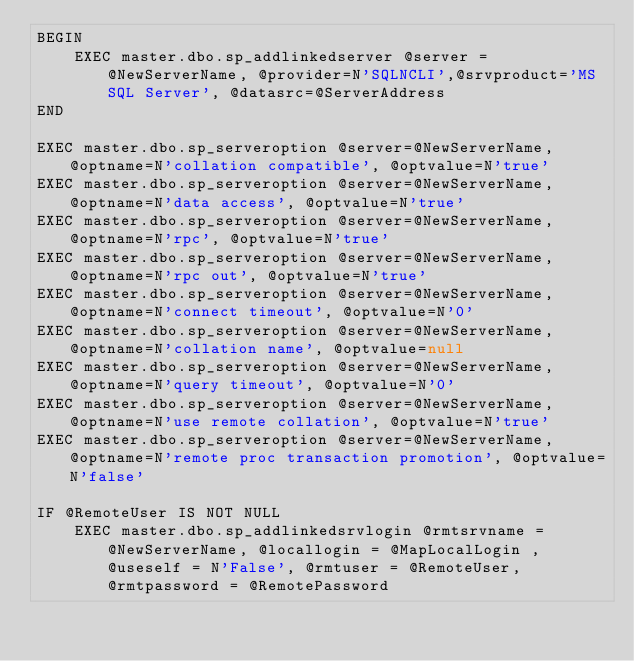<code> <loc_0><loc_0><loc_500><loc_500><_SQL_>BEGIN
	EXEC master.dbo.sp_addlinkedserver @server = @NewServerName, @provider=N'SQLNCLI',@srvproduct='MS SQL Server', @datasrc=@ServerAddress 
END

EXEC master.dbo.sp_serveroption @server=@NewServerName, @optname=N'collation compatible', @optvalue=N'true'
EXEC master.dbo.sp_serveroption @server=@NewServerName, @optname=N'data access', @optvalue=N'true'
EXEC master.dbo.sp_serveroption @server=@NewServerName, @optname=N'rpc', @optvalue=N'true'
EXEC master.dbo.sp_serveroption @server=@NewServerName, @optname=N'rpc out', @optvalue=N'true'
EXEC master.dbo.sp_serveroption @server=@NewServerName, @optname=N'connect timeout', @optvalue=N'0'
EXEC master.dbo.sp_serveroption @server=@NewServerName, @optname=N'collation name', @optvalue=null
EXEC master.dbo.sp_serveroption @server=@NewServerName, @optname=N'query timeout', @optvalue=N'0'
EXEC master.dbo.sp_serveroption @server=@NewServerName, @optname=N'use remote collation', @optvalue=N'true'
EXEC master.dbo.sp_serveroption @server=@NewServerName, @optname=N'remote proc transaction promotion', @optvalue=N'false'

IF @RemoteUser IS NOT NULL
	EXEC master.dbo.sp_addlinkedsrvlogin @rmtsrvname = @NewServerName, @locallogin = @MapLocalLogin , @useself = N'False', @rmtuser = @RemoteUser, @rmtpassword = @RemotePassword
</code> 